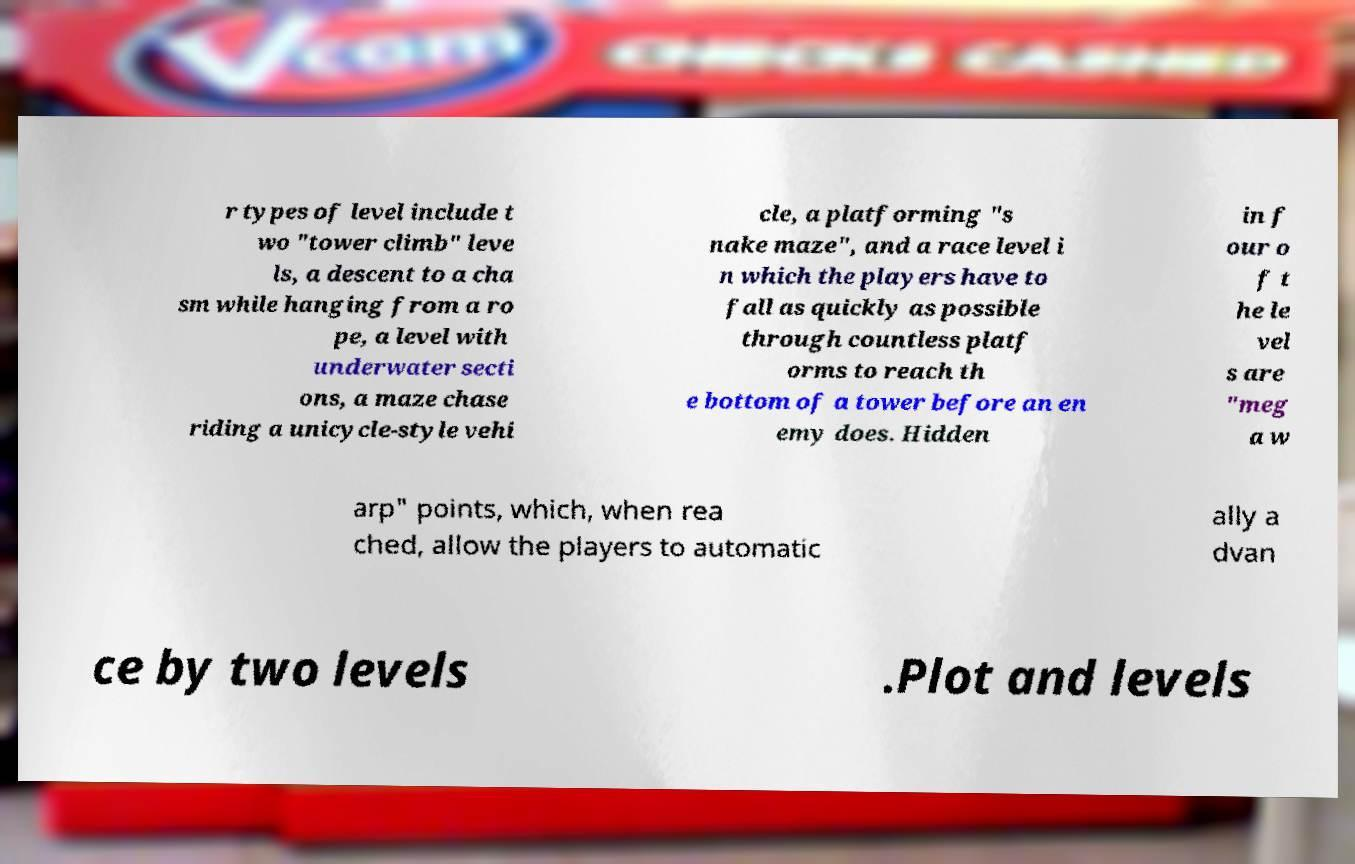Could you assist in decoding the text presented in this image and type it out clearly? r types of level include t wo "tower climb" leve ls, a descent to a cha sm while hanging from a ro pe, a level with underwater secti ons, a maze chase riding a unicycle-style vehi cle, a platforming "s nake maze", and a race level i n which the players have to fall as quickly as possible through countless platf orms to reach th e bottom of a tower before an en emy does. Hidden in f our o f t he le vel s are "meg a w arp" points, which, when rea ched, allow the players to automatic ally a dvan ce by two levels .Plot and levels 